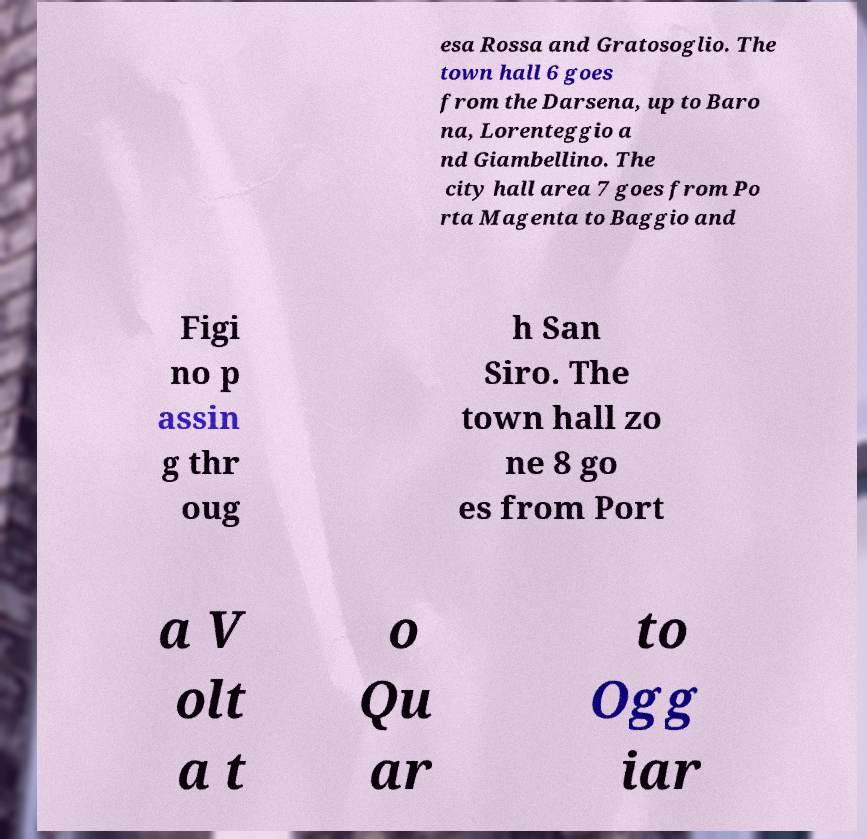For documentation purposes, I need the text within this image transcribed. Could you provide that? esa Rossa and Gratosoglio. The town hall 6 goes from the Darsena, up to Baro na, Lorenteggio a nd Giambellino. The city hall area 7 goes from Po rta Magenta to Baggio and Figi no p assin g thr oug h San Siro. The town hall zo ne 8 go es from Port a V olt a t o Qu ar to Ogg iar 